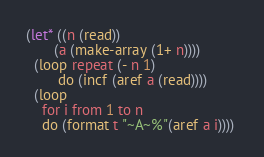Convert code to text. <code><loc_0><loc_0><loc_500><loc_500><_Lisp_>(let* ((n (read))
       (a (make-array (1+ n))))
  (loop repeat (- n 1)
        do (incf (aref a (read))))
  (loop
    for i from 1 to n 
    do (format t "~A~%"(aref a i)))) 
</code> 